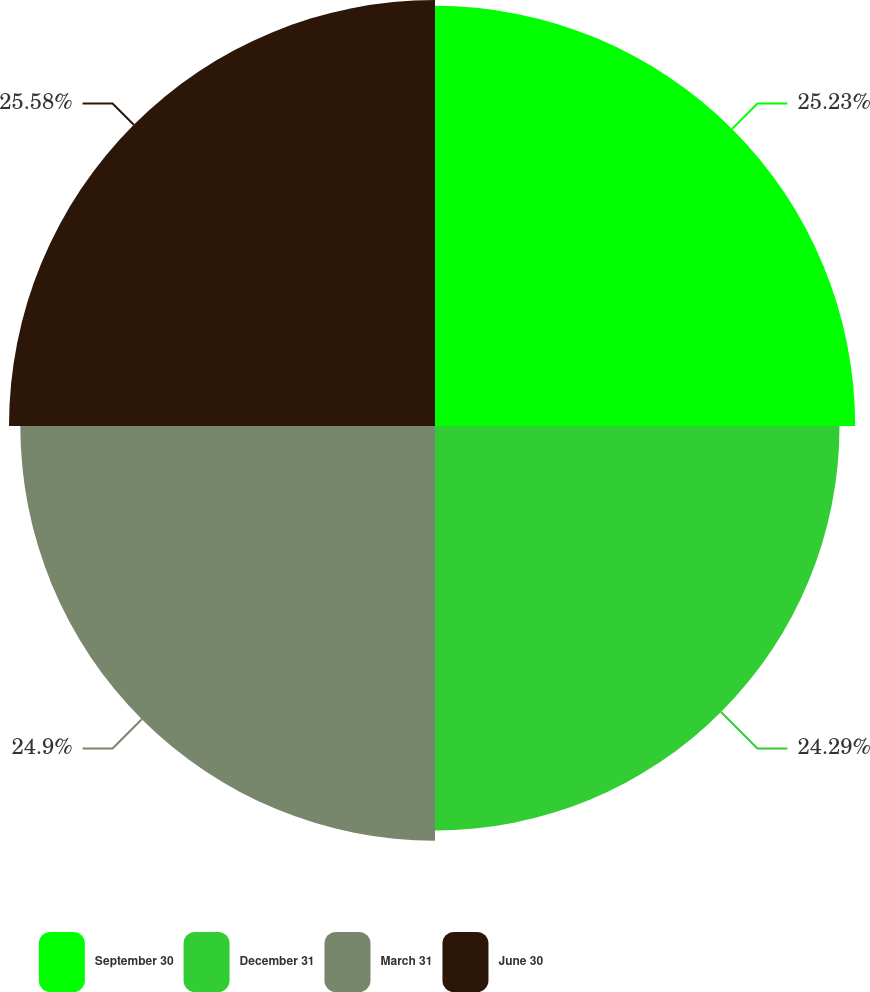Convert chart to OTSL. <chart><loc_0><loc_0><loc_500><loc_500><pie_chart><fcel>September 30<fcel>December 31<fcel>March 31<fcel>June 30<nl><fcel>25.23%<fcel>24.29%<fcel>24.9%<fcel>25.58%<nl></chart> 